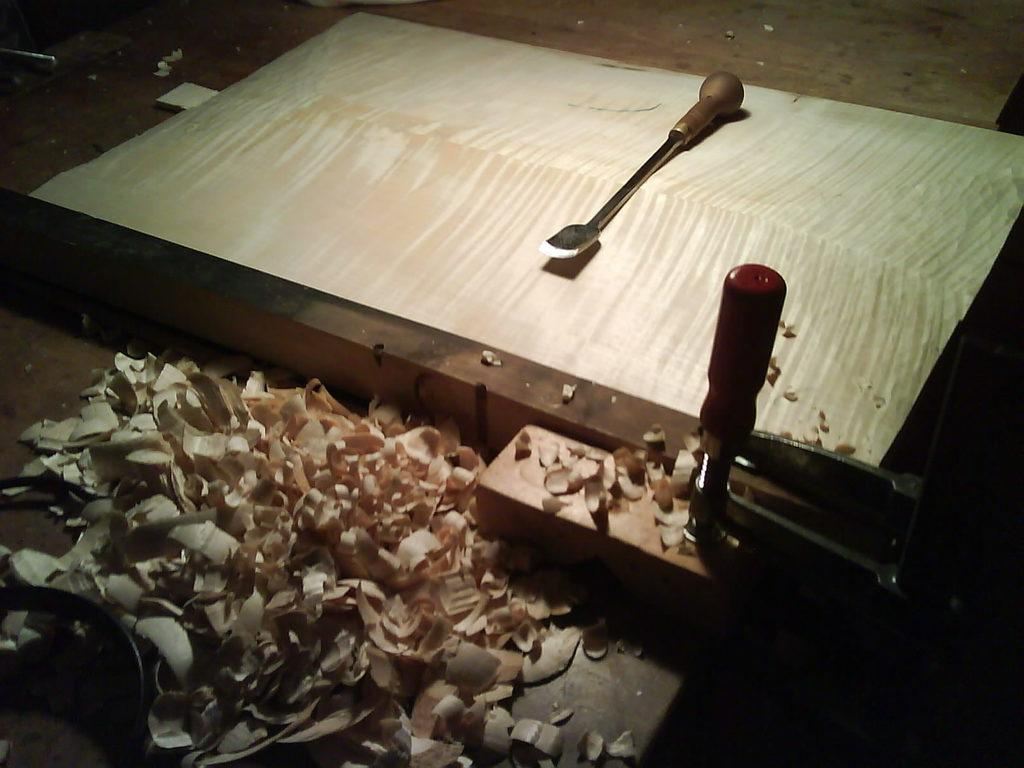What object can be seen in the image that is made of wood? There is a piece of wood in the image. What tool is present in the image that is used for peeling wood? There is a wood peeler in the image. What is the result of using the wood peeler on the piece of wood? There is dust that has been peeled from the wood. What type of bag is visible in the image? There is no bag present in the image. How many bricks are stacked on top of each other in the image? There are no bricks present in the image. 